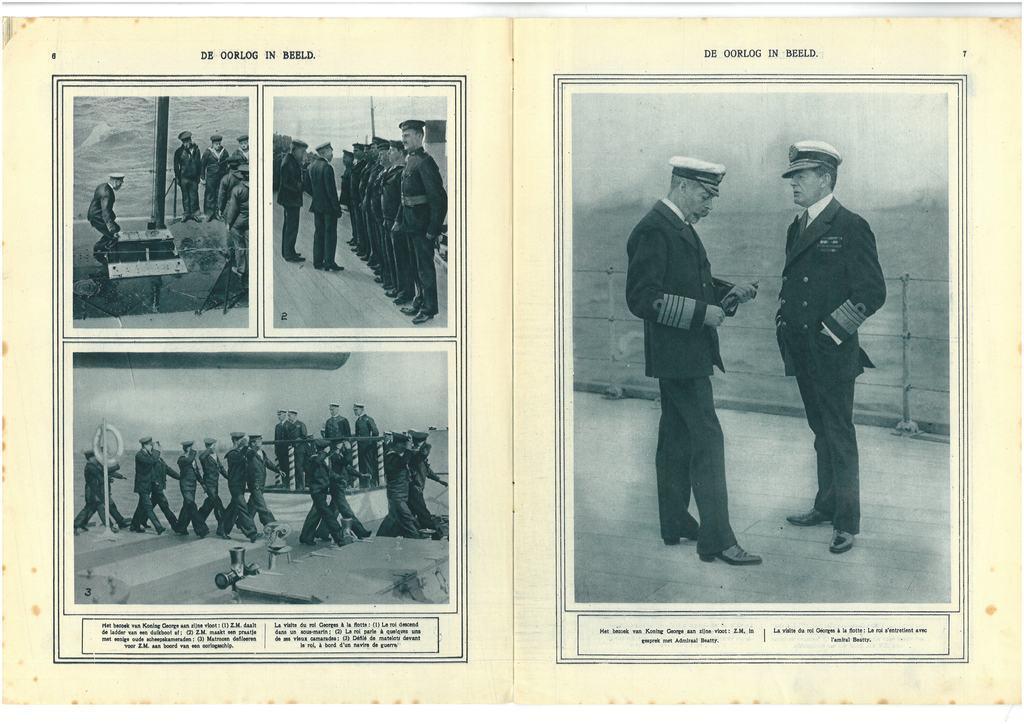In one or two sentences, can you explain what this image depicts? This is a book and here we can see black and white images of some people wearing uniforms and there are some objects. 